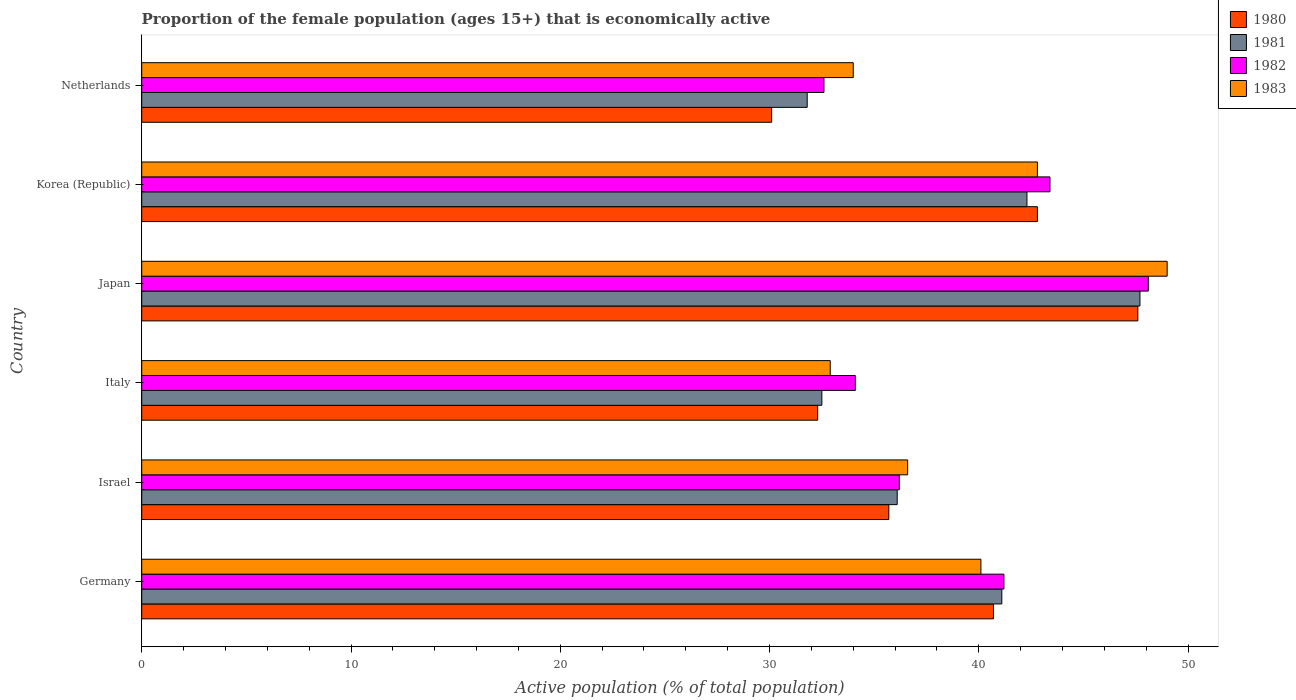Are the number of bars on each tick of the Y-axis equal?
Your answer should be compact. Yes. How many bars are there on the 2nd tick from the top?
Offer a very short reply. 4. How many bars are there on the 4th tick from the bottom?
Give a very brief answer. 4. What is the label of the 1st group of bars from the top?
Keep it short and to the point. Netherlands. In how many cases, is the number of bars for a given country not equal to the number of legend labels?
Keep it short and to the point. 0. What is the proportion of the female population that is economically active in 1982 in Netherlands?
Provide a succinct answer. 32.6. Across all countries, what is the maximum proportion of the female population that is economically active in 1980?
Offer a very short reply. 47.6. Across all countries, what is the minimum proportion of the female population that is economically active in 1980?
Provide a short and direct response. 30.1. In which country was the proportion of the female population that is economically active in 1983 minimum?
Make the answer very short. Italy. What is the total proportion of the female population that is economically active in 1981 in the graph?
Make the answer very short. 231.5. What is the difference between the proportion of the female population that is economically active in 1982 in Germany and that in Japan?
Offer a very short reply. -6.9. What is the difference between the proportion of the female population that is economically active in 1981 in Japan and the proportion of the female population that is economically active in 1982 in Italy?
Make the answer very short. 13.6. What is the average proportion of the female population that is economically active in 1981 per country?
Offer a terse response. 38.58. What is the difference between the proportion of the female population that is economically active in 1983 and proportion of the female population that is economically active in 1981 in Italy?
Ensure brevity in your answer.  0.4. In how many countries, is the proportion of the female population that is economically active in 1982 greater than 2 %?
Your answer should be compact. 6. What is the ratio of the proportion of the female population that is economically active in 1983 in Germany to that in Italy?
Offer a terse response. 1.22. Is the difference between the proportion of the female population that is economically active in 1983 in Japan and Netherlands greater than the difference between the proportion of the female population that is economically active in 1981 in Japan and Netherlands?
Ensure brevity in your answer.  No. What is the difference between the highest and the second highest proportion of the female population that is economically active in 1982?
Keep it short and to the point. 4.7. What is the difference between the highest and the lowest proportion of the female population that is economically active in 1980?
Your answer should be compact. 17.5. Is it the case that in every country, the sum of the proportion of the female population that is economically active in 1980 and proportion of the female population that is economically active in 1983 is greater than the sum of proportion of the female population that is economically active in 1981 and proportion of the female population that is economically active in 1982?
Provide a succinct answer. No. What does the 3rd bar from the top in Germany represents?
Your answer should be very brief. 1981. Is it the case that in every country, the sum of the proportion of the female population that is economically active in 1983 and proportion of the female population that is economically active in 1982 is greater than the proportion of the female population that is economically active in 1981?
Make the answer very short. Yes. How many countries are there in the graph?
Offer a terse response. 6. What is the difference between two consecutive major ticks on the X-axis?
Make the answer very short. 10. Does the graph contain grids?
Provide a succinct answer. No. Where does the legend appear in the graph?
Provide a short and direct response. Top right. How many legend labels are there?
Give a very brief answer. 4. What is the title of the graph?
Offer a terse response. Proportion of the female population (ages 15+) that is economically active. Does "2002" appear as one of the legend labels in the graph?
Offer a terse response. No. What is the label or title of the X-axis?
Provide a short and direct response. Active population (% of total population). What is the label or title of the Y-axis?
Provide a succinct answer. Country. What is the Active population (% of total population) in 1980 in Germany?
Your response must be concise. 40.7. What is the Active population (% of total population) of 1981 in Germany?
Make the answer very short. 41.1. What is the Active population (% of total population) in 1982 in Germany?
Make the answer very short. 41.2. What is the Active population (% of total population) in 1983 in Germany?
Ensure brevity in your answer.  40.1. What is the Active population (% of total population) in 1980 in Israel?
Provide a short and direct response. 35.7. What is the Active population (% of total population) in 1981 in Israel?
Ensure brevity in your answer.  36.1. What is the Active population (% of total population) of 1982 in Israel?
Offer a very short reply. 36.2. What is the Active population (% of total population) in 1983 in Israel?
Your answer should be compact. 36.6. What is the Active population (% of total population) of 1980 in Italy?
Ensure brevity in your answer.  32.3. What is the Active population (% of total population) of 1981 in Italy?
Provide a succinct answer. 32.5. What is the Active population (% of total population) of 1982 in Italy?
Provide a short and direct response. 34.1. What is the Active population (% of total population) of 1983 in Italy?
Offer a terse response. 32.9. What is the Active population (% of total population) of 1980 in Japan?
Keep it short and to the point. 47.6. What is the Active population (% of total population) of 1981 in Japan?
Provide a short and direct response. 47.7. What is the Active population (% of total population) in 1982 in Japan?
Keep it short and to the point. 48.1. What is the Active population (% of total population) in 1980 in Korea (Republic)?
Keep it short and to the point. 42.8. What is the Active population (% of total population) in 1981 in Korea (Republic)?
Your answer should be very brief. 42.3. What is the Active population (% of total population) of 1982 in Korea (Republic)?
Ensure brevity in your answer.  43.4. What is the Active population (% of total population) of 1983 in Korea (Republic)?
Your answer should be very brief. 42.8. What is the Active population (% of total population) in 1980 in Netherlands?
Provide a succinct answer. 30.1. What is the Active population (% of total population) in 1981 in Netherlands?
Make the answer very short. 31.8. What is the Active population (% of total population) of 1982 in Netherlands?
Make the answer very short. 32.6. What is the Active population (% of total population) of 1983 in Netherlands?
Offer a very short reply. 34. Across all countries, what is the maximum Active population (% of total population) in 1980?
Provide a succinct answer. 47.6. Across all countries, what is the maximum Active population (% of total population) of 1981?
Offer a very short reply. 47.7. Across all countries, what is the maximum Active population (% of total population) in 1982?
Make the answer very short. 48.1. Across all countries, what is the minimum Active population (% of total population) in 1980?
Make the answer very short. 30.1. Across all countries, what is the minimum Active population (% of total population) of 1981?
Your answer should be very brief. 31.8. Across all countries, what is the minimum Active population (% of total population) of 1982?
Offer a terse response. 32.6. Across all countries, what is the minimum Active population (% of total population) in 1983?
Provide a short and direct response. 32.9. What is the total Active population (% of total population) of 1980 in the graph?
Provide a succinct answer. 229.2. What is the total Active population (% of total population) of 1981 in the graph?
Your answer should be very brief. 231.5. What is the total Active population (% of total population) of 1982 in the graph?
Make the answer very short. 235.6. What is the total Active population (% of total population) in 1983 in the graph?
Provide a short and direct response. 235.4. What is the difference between the Active population (% of total population) in 1980 in Germany and that in Israel?
Keep it short and to the point. 5. What is the difference between the Active population (% of total population) of 1981 in Germany and that in Israel?
Make the answer very short. 5. What is the difference between the Active population (% of total population) in 1981 in Germany and that in Italy?
Offer a terse response. 8.6. What is the difference between the Active population (% of total population) in 1982 in Germany and that in Italy?
Your answer should be compact. 7.1. What is the difference between the Active population (% of total population) in 1983 in Germany and that in Italy?
Offer a terse response. 7.2. What is the difference between the Active population (% of total population) of 1981 in Germany and that in Japan?
Your answer should be very brief. -6.6. What is the difference between the Active population (% of total population) of 1982 in Germany and that in Japan?
Make the answer very short. -6.9. What is the difference between the Active population (% of total population) in 1983 in Germany and that in Japan?
Offer a terse response. -8.9. What is the difference between the Active population (% of total population) in 1980 in Germany and that in Korea (Republic)?
Your response must be concise. -2.1. What is the difference between the Active population (% of total population) of 1982 in Germany and that in Netherlands?
Keep it short and to the point. 8.6. What is the difference between the Active population (% of total population) in 1981 in Israel and that in Italy?
Offer a terse response. 3.6. What is the difference between the Active population (% of total population) of 1982 in Israel and that in Italy?
Offer a terse response. 2.1. What is the difference between the Active population (% of total population) in 1980 in Israel and that in Japan?
Keep it short and to the point. -11.9. What is the difference between the Active population (% of total population) in 1982 in Israel and that in Japan?
Ensure brevity in your answer.  -11.9. What is the difference between the Active population (% of total population) of 1983 in Israel and that in Japan?
Offer a terse response. -12.4. What is the difference between the Active population (% of total population) in 1980 in Israel and that in Korea (Republic)?
Ensure brevity in your answer.  -7.1. What is the difference between the Active population (% of total population) in 1981 in Israel and that in Netherlands?
Provide a short and direct response. 4.3. What is the difference between the Active population (% of total population) in 1982 in Israel and that in Netherlands?
Offer a terse response. 3.6. What is the difference between the Active population (% of total population) in 1983 in Israel and that in Netherlands?
Give a very brief answer. 2.6. What is the difference between the Active population (% of total population) of 1980 in Italy and that in Japan?
Ensure brevity in your answer.  -15.3. What is the difference between the Active population (% of total population) in 1981 in Italy and that in Japan?
Make the answer very short. -15.2. What is the difference between the Active population (% of total population) in 1983 in Italy and that in Japan?
Your answer should be compact. -16.1. What is the difference between the Active population (% of total population) in 1983 in Italy and that in Korea (Republic)?
Provide a short and direct response. -9.9. What is the difference between the Active population (% of total population) in 1980 in Italy and that in Netherlands?
Make the answer very short. 2.2. What is the difference between the Active population (% of total population) of 1982 in Italy and that in Netherlands?
Provide a short and direct response. 1.5. What is the difference between the Active population (% of total population) in 1983 in Italy and that in Netherlands?
Your answer should be compact. -1.1. What is the difference between the Active population (% of total population) in 1980 in Japan and that in Netherlands?
Ensure brevity in your answer.  17.5. What is the difference between the Active population (% of total population) in 1983 in Japan and that in Netherlands?
Provide a short and direct response. 15. What is the difference between the Active population (% of total population) of 1980 in Korea (Republic) and that in Netherlands?
Provide a succinct answer. 12.7. What is the difference between the Active population (% of total population) in 1982 in Korea (Republic) and that in Netherlands?
Offer a terse response. 10.8. What is the difference between the Active population (% of total population) in 1983 in Korea (Republic) and that in Netherlands?
Give a very brief answer. 8.8. What is the difference between the Active population (% of total population) in 1980 in Germany and the Active population (% of total population) in 1982 in Israel?
Provide a succinct answer. 4.5. What is the difference between the Active population (% of total population) of 1982 in Germany and the Active population (% of total population) of 1983 in Israel?
Your response must be concise. 4.6. What is the difference between the Active population (% of total population) of 1981 in Germany and the Active population (% of total population) of 1982 in Italy?
Give a very brief answer. 7. What is the difference between the Active population (% of total population) of 1981 in Germany and the Active population (% of total population) of 1983 in Italy?
Ensure brevity in your answer.  8.2. What is the difference between the Active population (% of total population) of 1982 in Germany and the Active population (% of total population) of 1983 in Italy?
Your answer should be very brief. 8.3. What is the difference between the Active population (% of total population) of 1980 in Germany and the Active population (% of total population) of 1981 in Japan?
Offer a terse response. -7. What is the difference between the Active population (% of total population) of 1980 in Germany and the Active population (% of total population) of 1982 in Japan?
Provide a succinct answer. -7.4. What is the difference between the Active population (% of total population) of 1981 in Germany and the Active population (% of total population) of 1982 in Japan?
Offer a very short reply. -7. What is the difference between the Active population (% of total population) of 1981 in Germany and the Active population (% of total population) of 1983 in Japan?
Provide a succinct answer. -7.9. What is the difference between the Active population (% of total population) of 1980 in Germany and the Active population (% of total population) of 1982 in Korea (Republic)?
Make the answer very short. -2.7. What is the difference between the Active population (% of total population) of 1980 in Germany and the Active population (% of total population) of 1983 in Korea (Republic)?
Provide a short and direct response. -2.1. What is the difference between the Active population (% of total population) of 1980 in Germany and the Active population (% of total population) of 1981 in Netherlands?
Provide a succinct answer. 8.9. What is the difference between the Active population (% of total population) of 1980 in Germany and the Active population (% of total population) of 1982 in Netherlands?
Offer a terse response. 8.1. What is the difference between the Active population (% of total population) in 1980 in Germany and the Active population (% of total population) in 1983 in Netherlands?
Your answer should be very brief. 6.7. What is the difference between the Active population (% of total population) in 1981 in Germany and the Active population (% of total population) in 1982 in Netherlands?
Make the answer very short. 8.5. What is the difference between the Active population (% of total population) in 1981 in Germany and the Active population (% of total population) in 1983 in Netherlands?
Offer a terse response. 7.1. What is the difference between the Active population (% of total population) in 1982 in Germany and the Active population (% of total population) in 1983 in Netherlands?
Provide a short and direct response. 7.2. What is the difference between the Active population (% of total population) in 1980 in Israel and the Active population (% of total population) in 1982 in Italy?
Make the answer very short. 1.6. What is the difference between the Active population (% of total population) of 1981 in Israel and the Active population (% of total population) of 1982 in Italy?
Keep it short and to the point. 2. What is the difference between the Active population (% of total population) in 1982 in Israel and the Active population (% of total population) in 1983 in Japan?
Your response must be concise. -12.8. What is the difference between the Active population (% of total population) of 1980 in Israel and the Active population (% of total population) of 1981 in Korea (Republic)?
Keep it short and to the point. -6.6. What is the difference between the Active population (% of total population) in 1980 in Israel and the Active population (% of total population) in 1983 in Korea (Republic)?
Ensure brevity in your answer.  -7.1. What is the difference between the Active population (% of total population) of 1981 in Israel and the Active population (% of total population) of 1983 in Korea (Republic)?
Make the answer very short. -6.7. What is the difference between the Active population (% of total population) in 1980 in Israel and the Active population (% of total population) in 1981 in Netherlands?
Offer a terse response. 3.9. What is the difference between the Active population (% of total population) of 1981 in Israel and the Active population (% of total population) of 1982 in Netherlands?
Provide a succinct answer. 3.5. What is the difference between the Active population (% of total population) in 1981 in Israel and the Active population (% of total population) in 1983 in Netherlands?
Give a very brief answer. 2.1. What is the difference between the Active population (% of total population) in 1982 in Israel and the Active population (% of total population) in 1983 in Netherlands?
Make the answer very short. 2.2. What is the difference between the Active population (% of total population) of 1980 in Italy and the Active population (% of total population) of 1981 in Japan?
Make the answer very short. -15.4. What is the difference between the Active population (% of total population) of 1980 in Italy and the Active population (% of total population) of 1982 in Japan?
Ensure brevity in your answer.  -15.8. What is the difference between the Active population (% of total population) of 1980 in Italy and the Active population (% of total population) of 1983 in Japan?
Offer a terse response. -16.7. What is the difference between the Active population (% of total population) in 1981 in Italy and the Active population (% of total population) in 1982 in Japan?
Ensure brevity in your answer.  -15.6. What is the difference between the Active population (% of total population) in 1981 in Italy and the Active population (% of total population) in 1983 in Japan?
Ensure brevity in your answer.  -16.5. What is the difference between the Active population (% of total population) of 1982 in Italy and the Active population (% of total population) of 1983 in Japan?
Make the answer very short. -14.9. What is the difference between the Active population (% of total population) in 1980 in Italy and the Active population (% of total population) in 1982 in Korea (Republic)?
Your response must be concise. -11.1. What is the difference between the Active population (% of total population) in 1980 in Italy and the Active population (% of total population) in 1983 in Korea (Republic)?
Provide a succinct answer. -10.5. What is the difference between the Active population (% of total population) of 1981 in Italy and the Active population (% of total population) of 1982 in Korea (Republic)?
Ensure brevity in your answer.  -10.9. What is the difference between the Active population (% of total population) in 1981 in Italy and the Active population (% of total population) in 1983 in Korea (Republic)?
Give a very brief answer. -10.3. What is the difference between the Active population (% of total population) in 1982 in Italy and the Active population (% of total population) in 1983 in Korea (Republic)?
Your answer should be compact. -8.7. What is the difference between the Active population (% of total population) of 1980 in Italy and the Active population (% of total population) of 1983 in Netherlands?
Your answer should be compact. -1.7. What is the difference between the Active population (% of total population) in 1982 in Italy and the Active population (% of total population) in 1983 in Netherlands?
Provide a short and direct response. 0.1. What is the difference between the Active population (% of total population) in 1980 in Japan and the Active population (% of total population) in 1981 in Korea (Republic)?
Make the answer very short. 5.3. What is the difference between the Active population (% of total population) of 1981 in Japan and the Active population (% of total population) of 1982 in Korea (Republic)?
Give a very brief answer. 4.3. What is the difference between the Active population (% of total population) in 1980 in Japan and the Active population (% of total population) in 1981 in Netherlands?
Give a very brief answer. 15.8. What is the difference between the Active population (% of total population) of 1980 in Japan and the Active population (% of total population) of 1982 in Netherlands?
Offer a very short reply. 15. What is the difference between the Active population (% of total population) of 1982 in Japan and the Active population (% of total population) of 1983 in Netherlands?
Your answer should be compact. 14.1. What is the difference between the Active population (% of total population) in 1980 in Korea (Republic) and the Active population (% of total population) in 1982 in Netherlands?
Your answer should be very brief. 10.2. What is the difference between the Active population (% of total population) in 1981 in Korea (Republic) and the Active population (% of total population) in 1982 in Netherlands?
Make the answer very short. 9.7. What is the difference between the Active population (% of total population) in 1982 in Korea (Republic) and the Active population (% of total population) in 1983 in Netherlands?
Give a very brief answer. 9.4. What is the average Active population (% of total population) in 1980 per country?
Your answer should be compact. 38.2. What is the average Active population (% of total population) in 1981 per country?
Your response must be concise. 38.58. What is the average Active population (% of total population) in 1982 per country?
Make the answer very short. 39.27. What is the average Active population (% of total population) in 1983 per country?
Provide a short and direct response. 39.23. What is the difference between the Active population (% of total population) in 1980 and Active population (% of total population) in 1981 in Germany?
Offer a very short reply. -0.4. What is the difference between the Active population (% of total population) of 1981 and Active population (% of total population) of 1982 in Germany?
Offer a very short reply. -0.1. What is the difference between the Active population (% of total population) of 1982 and Active population (% of total population) of 1983 in Germany?
Your response must be concise. 1.1. What is the difference between the Active population (% of total population) in 1980 and Active population (% of total population) in 1982 in Israel?
Provide a succinct answer. -0.5. What is the difference between the Active population (% of total population) in 1980 and Active population (% of total population) in 1983 in Israel?
Offer a terse response. -0.9. What is the difference between the Active population (% of total population) in 1981 and Active population (% of total population) in 1983 in Israel?
Ensure brevity in your answer.  -0.5. What is the difference between the Active population (% of total population) of 1980 and Active population (% of total population) of 1981 in Italy?
Make the answer very short. -0.2. What is the difference between the Active population (% of total population) in 1980 and Active population (% of total population) in 1983 in Italy?
Offer a very short reply. -0.6. What is the difference between the Active population (% of total population) in 1980 and Active population (% of total population) in 1981 in Japan?
Provide a succinct answer. -0.1. What is the difference between the Active population (% of total population) in 1980 and Active population (% of total population) in 1983 in Japan?
Provide a short and direct response. -1.4. What is the difference between the Active population (% of total population) of 1981 and Active population (% of total population) of 1982 in Japan?
Provide a short and direct response. -0.4. What is the difference between the Active population (% of total population) of 1982 and Active population (% of total population) of 1983 in Japan?
Provide a succinct answer. -0.9. What is the difference between the Active population (% of total population) of 1980 and Active population (% of total population) of 1981 in Korea (Republic)?
Provide a short and direct response. 0.5. What is the difference between the Active population (% of total population) in 1980 and Active population (% of total population) in 1983 in Korea (Republic)?
Your response must be concise. 0. What is the difference between the Active population (% of total population) of 1981 and Active population (% of total population) of 1983 in Korea (Republic)?
Your response must be concise. -0.5. What is the difference between the Active population (% of total population) in 1980 and Active population (% of total population) in 1981 in Netherlands?
Give a very brief answer. -1.7. What is the difference between the Active population (% of total population) in 1980 and Active population (% of total population) in 1982 in Netherlands?
Ensure brevity in your answer.  -2.5. What is the difference between the Active population (% of total population) in 1980 and Active population (% of total population) in 1983 in Netherlands?
Ensure brevity in your answer.  -3.9. What is the difference between the Active population (% of total population) of 1981 and Active population (% of total population) of 1982 in Netherlands?
Offer a very short reply. -0.8. What is the difference between the Active population (% of total population) in 1981 and Active population (% of total population) in 1983 in Netherlands?
Provide a succinct answer. -2.2. What is the ratio of the Active population (% of total population) in 1980 in Germany to that in Israel?
Offer a terse response. 1.14. What is the ratio of the Active population (% of total population) of 1981 in Germany to that in Israel?
Provide a short and direct response. 1.14. What is the ratio of the Active population (% of total population) in 1982 in Germany to that in Israel?
Your response must be concise. 1.14. What is the ratio of the Active population (% of total population) of 1983 in Germany to that in Israel?
Offer a terse response. 1.1. What is the ratio of the Active population (% of total population) of 1980 in Germany to that in Italy?
Provide a succinct answer. 1.26. What is the ratio of the Active population (% of total population) in 1981 in Germany to that in Italy?
Ensure brevity in your answer.  1.26. What is the ratio of the Active population (% of total population) in 1982 in Germany to that in Italy?
Make the answer very short. 1.21. What is the ratio of the Active population (% of total population) of 1983 in Germany to that in Italy?
Provide a short and direct response. 1.22. What is the ratio of the Active population (% of total population) of 1980 in Germany to that in Japan?
Give a very brief answer. 0.85. What is the ratio of the Active population (% of total population) of 1981 in Germany to that in Japan?
Give a very brief answer. 0.86. What is the ratio of the Active population (% of total population) of 1982 in Germany to that in Japan?
Your answer should be compact. 0.86. What is the ratio of the Active population (% of total population) of 1983 in Germany to that in Japan?
Make the answer very short. 0.82. What is the ratio of the Active population (% of total population) of 1980 in Germany to that in Korea (Republic)?
Give a very brief answer. 0.95. What is the ratio of the Active population (% of total population) in 1981 in Germany to that in Korea (Republic)?
Offer a terse response. 0.97. What is the ratio of the Active population (% of total population) in 1982 in Germany to that in Korea (Republic)?
Offer a very short reply. 0.95. What is the ratio of the Active population (% of total population) in 1983 in Germany to that in Korea (Republic)?
Ensure brevity in your answer.  0.94. What is the ratio of the Active population (% of total population) in 1980 in Germany to that in Netherlands?
Offer a terse response. 1.35. What is the ratio of the Active population (% of total population) in 1981 in Germany to that in Netherlands?
Provide a short and direct response. 1.29. What is the ratio of the Active population (% of total population) in 1982 in Germany to that in Netherlands?
Offer a very short reply. 1.26. What is the ratio of the Active population (% of total population) in 1983 in Germany to that in Netherlands?
Offer a terse response. 1.18. What is the ratio of the Active population (% of total population) in 1980 in Israel to that in Italy?
Offer a very short reply. 1.11. What is the ratio of the Active population (% of total population) of 1981 in Israel to that in Italy?
Your response must be concise. 1.11. What is the ratio of the Active population (% of total population) in 1982 in Israel to that in Italy?
Ensure brevity in your answer.  1.06. What is the ratio of the Active population (% of total population) of 1983 in Israel to that in Italy?
Keep it short and to the point. 1.11. What is the ratio of the Active population (% of total population) of 1980 in Israel to that in Japan?
Provide a succinct answer. 0.75. What is the ratio of the Active population (% of total population) in 1981 in Israel to that in Japan?
Offer a terse response. 0.76. What is the ratio of the Active population (% of total population) in 1982 in Israel to that in Japan?
Make the answer very short. 0.75. What is the ratio of the Active population (% of total population) of 1983 in Israel to that in Japan?
Make the answer very short. 0.75. What is the ratio of the Active population (% of total population) of 1980 in Israel to that in Korea (Republic)?
Provide a short and direct response. 0.83. What is the ratio of the Active population (% of total population) in 1981 in Israel to that in Korea (Republic)?
Offer a terse response. 0.85. What is the ratio of the Active population (% of total population) of 1982 in Israel to that in Korea (Republic)?
Give a very brief answer. 0.83. What is the ratio of the Active population (% of total population) in 1983 in Israel to that in Korea (Republic)?
Your response must be concise. 0.86. What is the ratio of the Active population (% of total population) in 1980 in Israel to that in Netherlands?
Provide a succinct answer. 1.19. What is the ratio of the Active population (% of total population) in 1981 in Israel to that in Netherlands?
Keep it short and to the point. 1.14. What is the ratio of the Active population (% of total population) of 1982 in Israel to that in Netherlands?
Keep it short and to the point. 1.11. What is the ratio of the Active population (% of total population) of 1983 in Israel to that in Netherlands?
Your response must be concise. 1.08. What is the ratio of the Active population (% of total population) of 1980 in Italy to that in Japan?
Offer a very short reply. 0.68. What is the ratio of the Active population (% of total population) in 1981 in Italy to that in Japan?
Offer a terse response. 0.68. What is the ratio of the Active population (% of total population) of 1982 in Italy to that in Japan?
Provide a short and direct response. 0.71. What is the ratio of the Active population (% of total population) in 1983 in Italy to that in Japan?
Provide a short and direct response. 0.67. What is the ratio of the Active population (% of total population) in 1980 in Italy to that in Korea (Republic)?
Ensure brevity in your answer.  0.75. What is the ratio of the Active population (% of total population) of 1981 in Italy to that in Korea (Republic)?
Ensure brevity in your answer.  0.77. What is the ratio of the Active population (% of total population) of 1982 in Italy to that in Korea (Republic)?
Provide a succinct answer. 0.79. What is the ratio of the Active population (% of total population) of 1983 in Italy to that in Korea (Republic)?
Provide a succinct answer. 0.77. What is the ratio of the Active population (% of total population) in 1980 in Italy to that in Netherlands?
Your answer should be compact. 1.07. What is the ratio of the Active population (% of total population) in 1982 in Italy to that in Netherlands?
Offer a terse response. 1.05. What is the ratio of the Active population (% of total population) of 1983 in Italy to that in Netherlands?
Provide a succinct answer. 0.97. What is the ratio of the Active population (% of total population) of 1980 in Japan to that in Korea (Republic)?
Offer a terse response. 1.11. What is the ratio of the Active population (% of total population) in 1981 in Japan to that in Korea (Republic)?
Keep it short and to the point. 1.13. What is the ratio of the Active population (% of total population) in 1982 in Japan to that in Korea (Republic)?
Your answer should be compact. 1.11. What is the ratio of the Active population (% of total population) in 1983 in Japan to that in Korea (Republic)?
Offer a terse response. 1.14. What is the ratio of the Active population (% of total population) in 1980 in Japan to that in Netherlands?
Ensure brevity in your answer.  1.58. What is the ratio of the Active population (% of total population) of 1981 in Japan to that in Netherlands?
Ensure brevity in your answer.  1.5. What is the ratio of the Active population (% of total population) in 1982 in Japan to that in Netherlands?
Your answer should be compact. 1.48. What is the ratio of the Active population (% of total population) of 1983 in Japan to that in Netherlands?
Your answer should be compact. 1.44. What is the ratio of the Active population (% of total population) in 1980 in Korea (Republic) to that in Netherlands?
Give a very brief answer. 1.42. What is the ratio of the Active population (% of total population) of 1981 in Korea (Republic) to that in Netherlands?
Make the answer very short. 1.33. What is the ratio of the Active population (% of total population) in 1982 in Korea (Republic) to that in Netherlands?
Give a very brief answer. 1.33. What is the ratio of the Active population (% of total population) in 1983 in Korea (Republic) to that in Netherlands?
Your answer should be very brief. 1.26. What is the difference between the highest and the second highest Active population (% of total population) of 1980?
Offer a very short reply. 4.8. What is the difference between the highest and the second highest Active population (% of total population) in 1983?
Give a very brief answer. 6.2. 